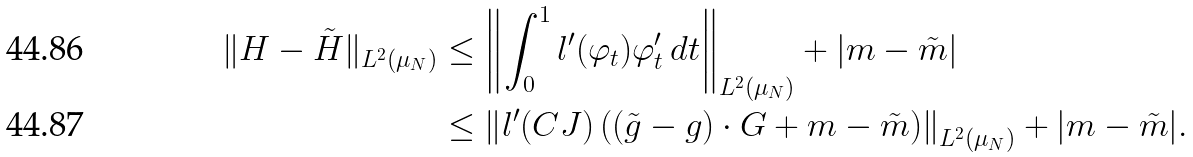<formula> <loc_0><loc_0><loc_500><loc_500>\| H - \tilde { H } \| _ { L ^ { 2 } ( \mu _ { N } ) } & \leq \left \| \int _ { 0 } ^ { 1 } l ^ { \prime } ( \varphi _ { t } ) \varphi ^ { \prime } _ { t } \, d t \right \| _ { L ^ { 2 } ( \mu _ { N } ) } + | m - \tilde { m } | \\ & \leq \left \| l ^ { \prime } ( C J ) \left ( ( \tilde { g } - g ) \cdot G + m - \tilde { m } \right ) \right \| _ { L ^ { 2 } ( \mu _ { N } ) } + | m - \tilde { m } | .</formula> 